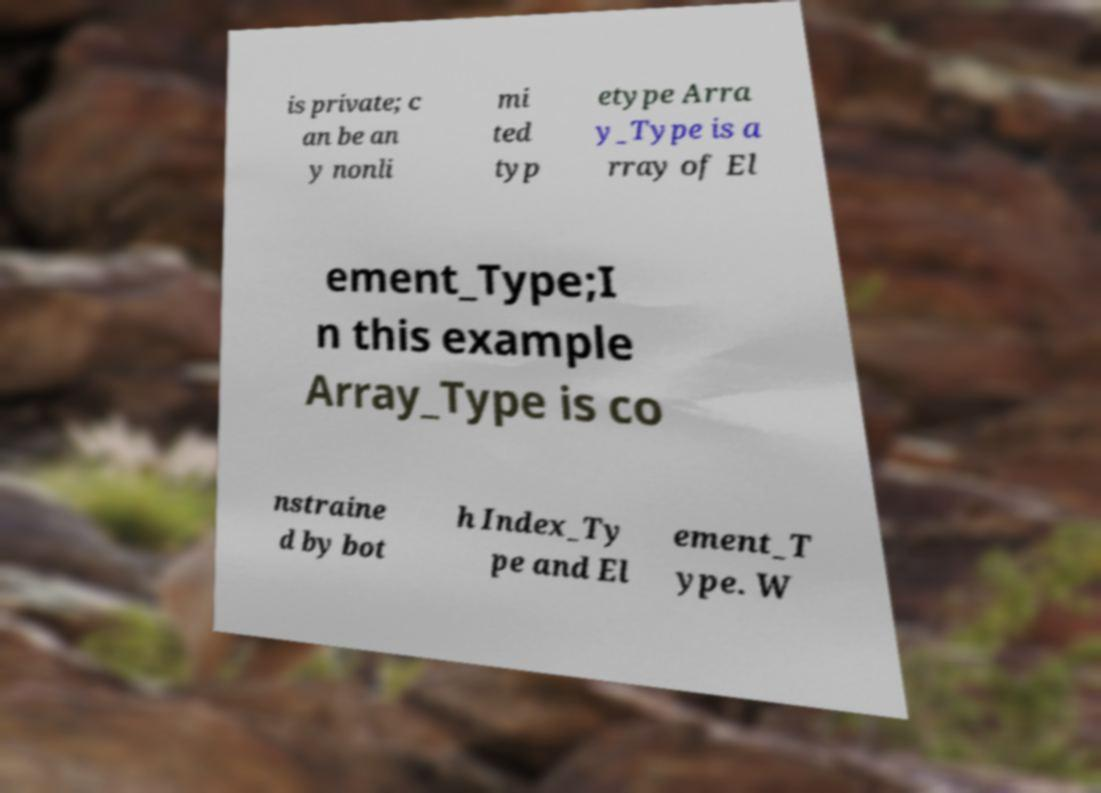For documentation purposes, I need the text within this image transcribed. Could you provide that? is private; c an be an y nonli mi ted typ etype Arra y_Type is a rray of El ement_Type;I n this example Array_Type is co nstraine d by bot h Index_Ty pe and El ement_T ype. W 